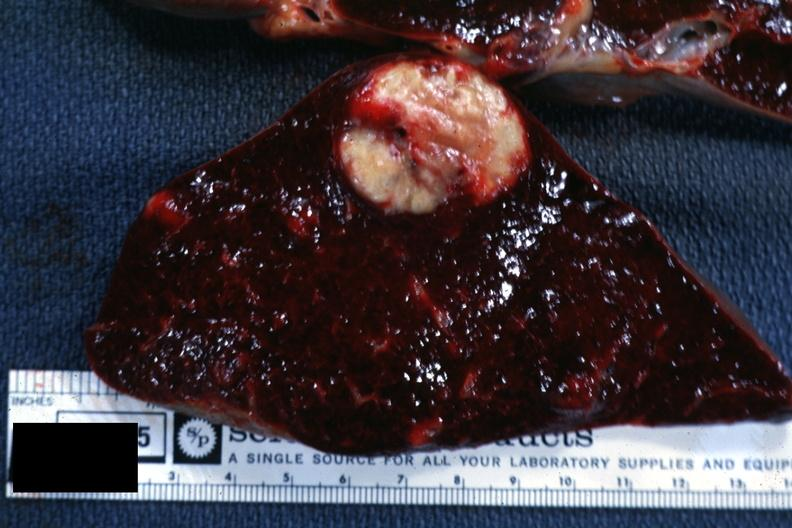s spleen present?
Answer the question using a single word or phrase. Yes 